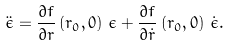Convert formula to latex. <formula><loc_0><loc_0><loc_500><loc_500>\ddot { \epsilon } = \frac { \partial f } { \partial r } \left ( r _ { 0 } , 0 \right ) \, \epsilon + \frac { \partial f } { \partial \dot { r } } \left ( r _ { 0 } , 0 \right ) \, \dot { \epsilon } .</formula> 